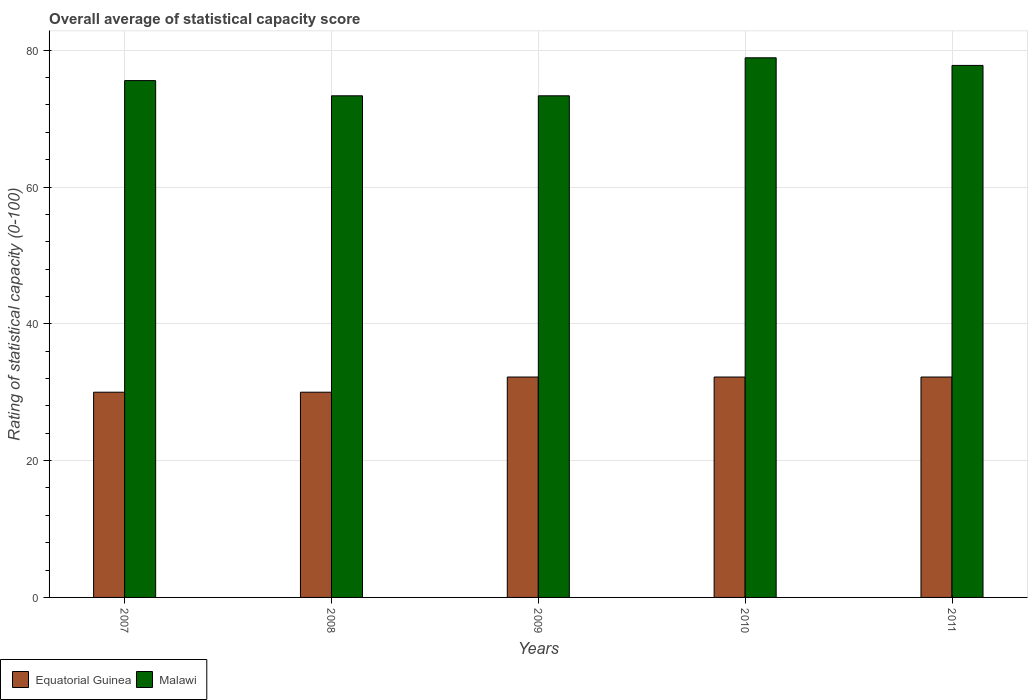How many groups of bars are there?
Your answer should be compact. 5. Are the number of bars per tick equal to the number of legend labels?
Provide a succinct answer. Yes. How many bars are there on the 2nd tick from the right?
Give a very brief answer. 2. What is the label of the 3rd group of bars from the left?
Make the answer very short. 2009. In how many cases, is the number of bars for a given year not equal to the number of legend labels?
Offer a very short reply. 0. What is the rating of statistical capacity in Equatorial Guinea in 2010?
Provide a succinct answer. 32.22. Across all years, what is the maximum rating of statistical capacity in Malawi?
Offer a very short reply. 78.89. What is the total rating of statistical capacity in Equatorial Guinea in the graph?
Offer a very short reply. 156.67. What is the difference between the rating of statistical capacity in Equatorial Guinea in 2009 and that in 2010?
Make the answer very short. 0. What is the difference between the rating of statistical capacity in Equatorial Guinea in 2010 and the rating of statistical capacity in Malawi in 2009?
Provide a succinct answer. -41.11. What is the average rating of statistical capacity in Equatorial Guinea per year?
Offer a very short reply. 31.33. In the year 2007, what is the difference between the rating of statistical capacity in Malawi and rating of statistical capacity in Equatorial Guinea?
Offer a terse response. 45.56. What is the ratio of the rating of statistical capacity in Equatorial Guinea in 2008 to that in 2010?
Your answer should be compact. 0.93. Is the rating of statistical capacity in Malawi in 2009 less than that in 2010?
Your response must be concise. Yes. Is the difference between the rating of statistical capacity in Malawi in 2010 and 2011 greater than the difference between the rating of statistical capacity in Equatorial Guinea in 2010 and 2011?
Offer a very short reply. Yes. What is the difference between the highest and the second highest rating of statistical capacity in Malawi?
Ensure brevity in your answer.  1.11. What is the difference between the highest and the lowest rating of statistical capacity in Malawi?
Ensure brevity in your answer.  5.56. Is the sum of the rating of statistical capacity in Equatorial Guinea in 2008 and 2011 greater than the maximum rating of statistical capacity in Malawi across all years?
Make the answer very short. No. What does the 2nd bar from the left in 2007 represents?
Your answer should be very brief. Malawi. What does the 1st bar from the right in 2008 represents?
Offer a terse response. Malawi. How many years are there in the graph?
Ensure brevity in your answer.  5. Does the graph contain grids?
Give a very brief answer. Yes. How many legend labels are there?
Make the answer very short. 2. What is the title of the graph?
Provide a short and direct response. Overall average of statistical capacity score. What is the label or title of the Y-axis?
Your answer should be compact. Rating of statistical capacity (0-100). What is the Rating of statistical capacity (0-100) in Malawi in 2007?
Keep it short and to the point. 75.56. What is the Rating of statistical capacity (0-100) of Equatorial Guinea in 2008?
Your response must be concise. 30. What is the Rating of statistical capacity (0-100) of Malawi in 2008?
Give a very brief answer. 73.33. What is the Rating of statistical capacity (0-100) of Equatorial Guinea in 2009?
Give a very brief answer. 32.22. What is the Rating of statistical capacity (0-100) of Malawi in 2009?
Your answer should be compact. 73.33. What is the Rating of statistical capacity (0-100) in Equatorial Guinea in 2010?
Ensure brevity in your answer.  32.22. What is the Rating of statistical capacity (0-100) in Malawi in 2010?
Your answer should be compact. 78.89. What is the Rating of statistical capacity (0-100) of Equatorial Guinea in 2011?
Offer a very short reply. 32.22. What is the Rating of statistical capacity (0-100) of Malawi in 2011?
Make the answer very short. 77.78. Across all years, what is the maximum Rating of statistical capacity (0-100) in Equatorial Guinea?
Your answer should be very brief. 32.22. Across all years, what is the maximum Rating of statistical capacity (0-100) in Malawi?
Provide a succinct answer. 78.89. Across all years, what is the minimum Rating of statistical capacity (0-100) of Equatorial Guinea?
Keep it short and to the point. 30. Across all years, what is the minimum Rating of statistical capacity (0-100) of Malawi?
Give a very brief answer. 73.33. What is the total Rating of statistical capacity (0-100) of Equatorial Guinea in the graph?
Provide a succinct answer. 156.67. What is the total Rating of statistical capacity (0-100) of Malawi in the graph?
Keep it short and to the point. 378.89. What is the difference between the Rating of statistical capacity (0-100) in Equatorial Guinea in 2007 and that in 2008?
Offer a very short reply. 0. What is the difference between the Rating of statistical capacity (0-100) in Malawi in 2007 and that in 2008?
Ensure brevity in your answer.  2.22. What is the difference between the Rating of statistical capacity (0-100) in Equatorial Guinea in 2007 and that in 2009?
Your answer should be very brief. -2.22. What is the difference between the Rating of statistical capacity (0-100) in Malawi in 2007 and that in 2009?
Your answer should be compact. 2.22. What is the difference between the Rating of statistical capacity (0-100) in Equatorial Guinea in 2007 and that in 2010?
Offer a terse response. -2.22. What is the difference between the Rating of statistical capacity (0-100) of Equatorial Guinea in 2007 and that in 2011?
Your answer should be compact. -2.22. What is the difference between the Rating of statistical capacity (0-100) in Malawi in 2007 and that in 2011?
Offer a very short reply. -2.22. What is the difference between the Rating of statistical capacity (0-100) in Equatorial Guinea in 2008 and that in 2009?
Offer a terse response. -2.22. What is the difference between the Rating of statistical capacity (0-100) of Malawi in 2008 and that in 2009?
Provide a short and direct response. 0. What is the difference between the Rating of statistical capacity (0-100) in Equatorial Guinea in 2008 and that in 2010?
Make the answer very short. -2.22. What is the difference between the Rating of statistical capacity (0-100) in Malawi in 2008 and that in 2010?
Keep it short and to the point. -5.56. What is the difference between the Rating of statistical capacity (0-100) in Equatorial Guinea in 2008 and that in 2011?
Give a very brief answer. -2.22. What is the difference between the Rating of statistical capacity (0-100) of Malawi in 2008 and that in 2011?
Provide a succinct answer. -4.44. What is the difference between the Rating of statistical capacity (0-100) of Equatorial Guinea in 2009 and that in 2010?
Your answer should be very brief. 0. What is the difference between the Rating of statistical capacity (0-100) in Malawi in 2009 and that in 2010?
Your response must be concise. -5.56. What is the difference between the Rating of statistical capacity (0-100) in Malawi in 2009 and that in 2011?
Offer a very short reply. -4.44. What is the difference between the Rating of statistical capacity (0-100) in Equatorial Guinea in 2007 and the Rating of statistical capacity (0-100) in Malawi in 2008?
Provide a succinct answer. -43.33. What is the difference between the Rating of statistical capacity (0-100) of Equatorial Guinea in 2007 and the Rating of statistical capacity (0-100) of Malawi in 2009?
Your answer should be compact. -43.33. What is the difference between the Rating of statistical capacity (0-100) of Equatorial Guinea in 2007 and the Rating of statistical capacity (0-100) of Malawi in 2010?
Ensure brevity in your answer.  -48.89. What is the difference between the Rating of statistical capacity (0-100) of Equatorial Guinea in 2007 and the Rating of statistical capacity (0-100) of Malawi in 2011?
Make the answer very short. -47.78. What is the difference between the Rating of statistical capacity (0-100) of Equatorial Guinea in 2008 and the Rating of statistical capacity (0-100) of Malawi in 2009?
Keep it short and to the point. -43.33. What is the difference between the Rating of statistical capacity (0-100) of Equatorial Guinea in 2008 and the Rating of statistical capacity (0-100) of Malawi in 2010?
Provide a short and direct response. -48.89. What is the difference between the Rating of statistical capacity (0-100) in Equatorial Guinea in 2008 and the Rating of statistical capacity (0-100) in Malawi in 2011?
Offer a terse response. -47.78. What is the difference between the Rating of statistical capacity (0-100) of Equatorial Guinea in 2009 and the Rating of statistical capacity (0-100) of Malawi in 2010?
Provide a short and direct response. -46.67. What is the difference between the Rating of statistical capacity (0-100) of Equatorial Guinea in 2009 and the Rating of statistical capacity (0-100) of Malawi in 2011?
Your answer should be very brief. -45.56. What is the difference between the Rating of statistical capacity (0-100) of Equatorial Guinea in 2010 and the Rating of statistical capacity (0-100) of Malawi in 2011?
Your answer should be very brief. -45.56. What is the average Rating of statistical capacity (0-100) in Equatorial Guinea per year?
Ensure brevity in your answer.  31.33. What is the average Rating of statistical capacity (0-100) of Malawi per year?
Your response must be concise. 75.78. In the year 2007, what is the difference between the Rating of statistical capacity (0-100) of Equatorial Guinea and Rating of statistical capacity (0-100) of Malawi?
Offer a terse response. -45.56. In the year 2008, what is the difference between the Rating of statistical capacity (0-100) in Equatorial Guinea and Rating of statistical capacity (0-100) in Malawi?
Your answer should be very brief. -43.33. In the year 2009, what is the difference between the Rating of statistical capacity (0-100) of Equatorial Guinea and Rating of statistical capacity (0-100) of Malawi?
Provide a short and direct response. -41.11. In the year 2010, what is the difference between the Rating of statistical capacity (0-100) in Equatorial Guinea and Rating of statistical capacity (0-100) in Malawi?
Ensure brevity in your answer.  -46.67. In the year 2011, what is the difference between the Rating of statistical capacity (0-100) in Equatorial Guinea and Rating of statistical capacity (0-100) in Malawi?
Give a very brief answer. -45.56. What is the ratio of the Rating of statistical capacity (0-100) of Malawi in 2007 to that in 2008?
Keep it short and to the point. 1.03. What is the ratio of the Rating of statistical capacity (0-100) of Equatorial Guinea in 2007 to that in 2009?
Provide a succinct answer. 0.93. What is the ratio of the Rating of statistical capacity (0-100) of Malawi in 2007 to that in 2009?
Your response must be concise. 1.03. What is the ratio of the Rating of statistical capacity (0-100) of Equatorial Guinea in 2007 to that in 2010?
Provide a succinct answer. 0.93. What is the ratio of the Rating of statistical capacity (0-100) in Malawi in 2007 to that in 2010?
Offer a very short reply. 0.96. What is the ratio of the Rating of statistical capacity (0-100) of Malawi in 2007 to that in 2011?
Give a very brief answer. 0.97. What is the ratio of the Rating of statistical capacity (0-100) in Equatorial Guinea in 2008 to that in 2010?
Offer a terse response. 0.93. What is the ratio of the Rating of statistical capacity (0-100) in Malawi in 2008 to that in 2010?
Your answer should be compact. 0.93. What is the ratio of the Rating of statistical capacity (0-100) of Malawi in 2008 to that in 2011?
Your answer should be compact. 0.94. What is the ratio of the Rating of statistical capacity (0-100) of Malawi in 2009 to that in 2010?
Offer a terse response. 0.93. What is the ratio of the Rating of statistical capacity (0-100) of Malawi in 2009 to that in 2011?
Make the answer very short. 0.94. What is the ratio of the Rating of statistical capacity (0-100) in Equatorial Guinea in 2010 to that in 2011?
Provide a succinct answer. 1. What is the ratio of the Rating of statistical capacity (0-100) of Malawi in 2010 to that in 2011?
Ensure brevity in your answer.  1.01. What is the difference between the highest and the second highest Rating of statistical capacity (0-100) of Equatorial Guinea?
Ensure brevity in your answer.  0. What is the difference between the highest and the second highest Rating of statistical capacity (0-100) in Malawi?
Provide a short and direct response. 1.11. What is the difference between the highest and the lowest Rating of statistical capacity (0-100) of Equatorial Guinea?
Your response must be concise. 2.22. What is the difference between the highest and the lowest Rating of statistical capacity (0-100) of Malawi?
Make the answer very short. 5.56. 